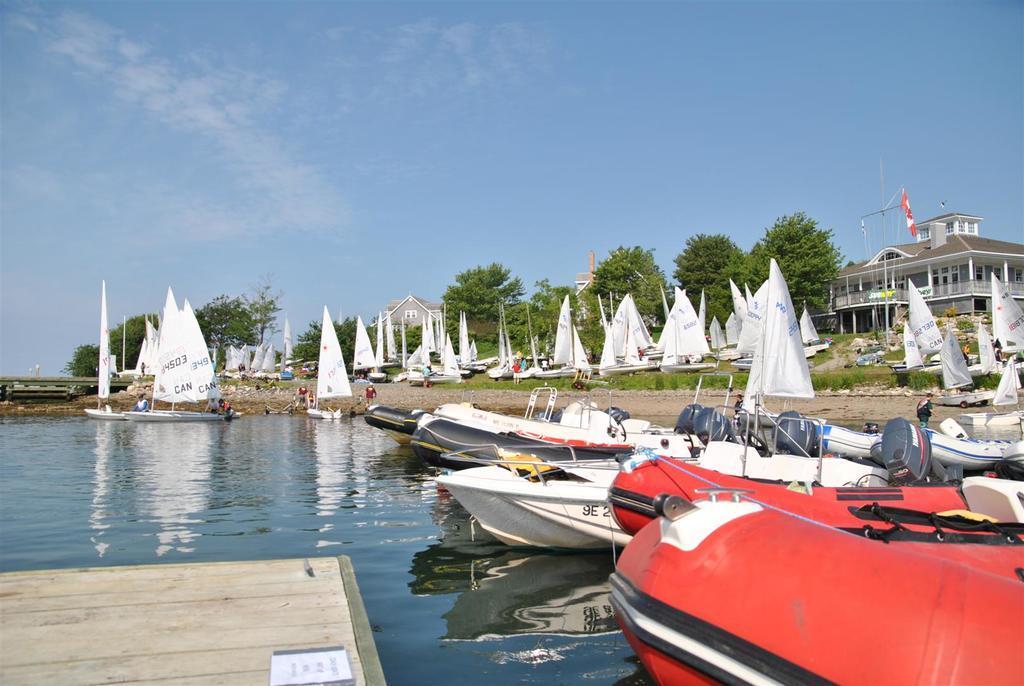Can you describe this image briefly? Here we can see boats,flags,grass and water. Background we can see building,trees and sky. 